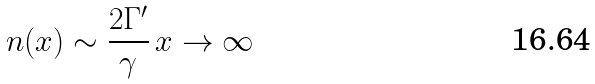<formula> <loc_0><loc_0><loc_500><loc_500>n ( x ) \sim \frac { 2 \Gamma ^ { \prime } } { \gamma } \, x \to \infty</formula> 